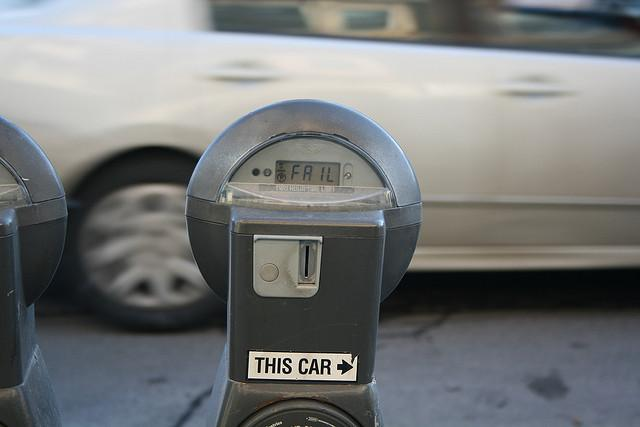Which direction is this meter pointing towards?

Choices:
A) left
B) down
C) right
D) up right 